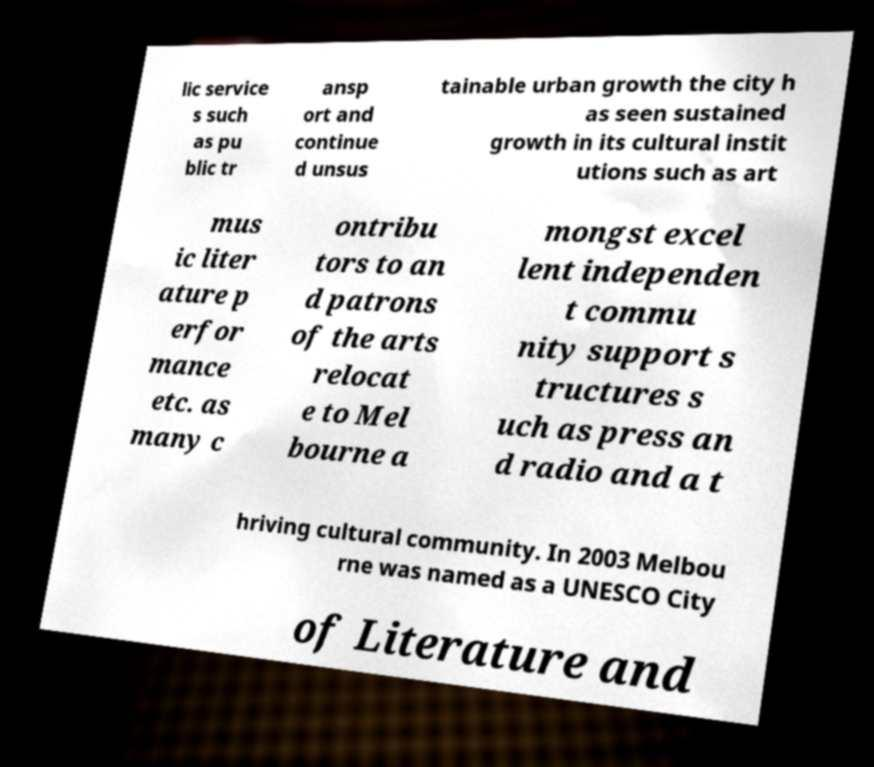For documentation purposes, I need the text within this image transcribed. Could you provide that? lic service s such as pu blic tr ansp ort and continue d unsus tainable urban growth the city h as seen sustained growth in its cultural instit utions such as art mus ic liter ature p erfor mance etc. as many c ontribu tors to an d patrons of the arts relocat e to Mel bourne a mongst excel lent independen t commu nity support s tructures s uch as press an d radio and a t hriving cultural community. In 2003 Melbou rne was named as a UNESCO City of Literature and 